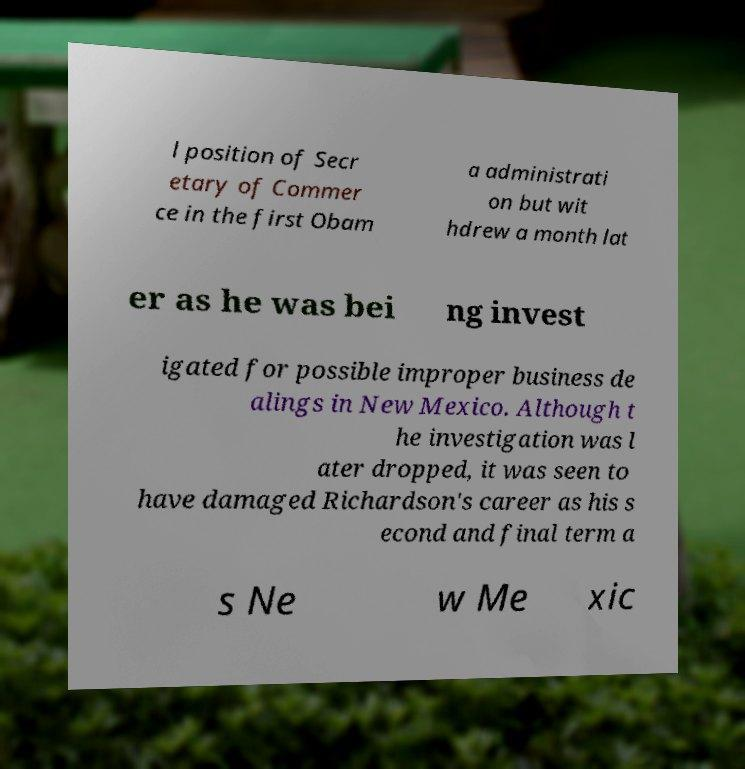Can you accurately transcribe the text from the provided image for me? l position of Secr etary of Commer ce in the first Obam a administrati on but wit hdrew a month lat er as he was bei ng invest igated for possible improper business de alings in New Mexico. Although t he investigation was l ater dropped, it was seen to have damaged Richardson's career as his s econd and final term a s Ne w Me xic 